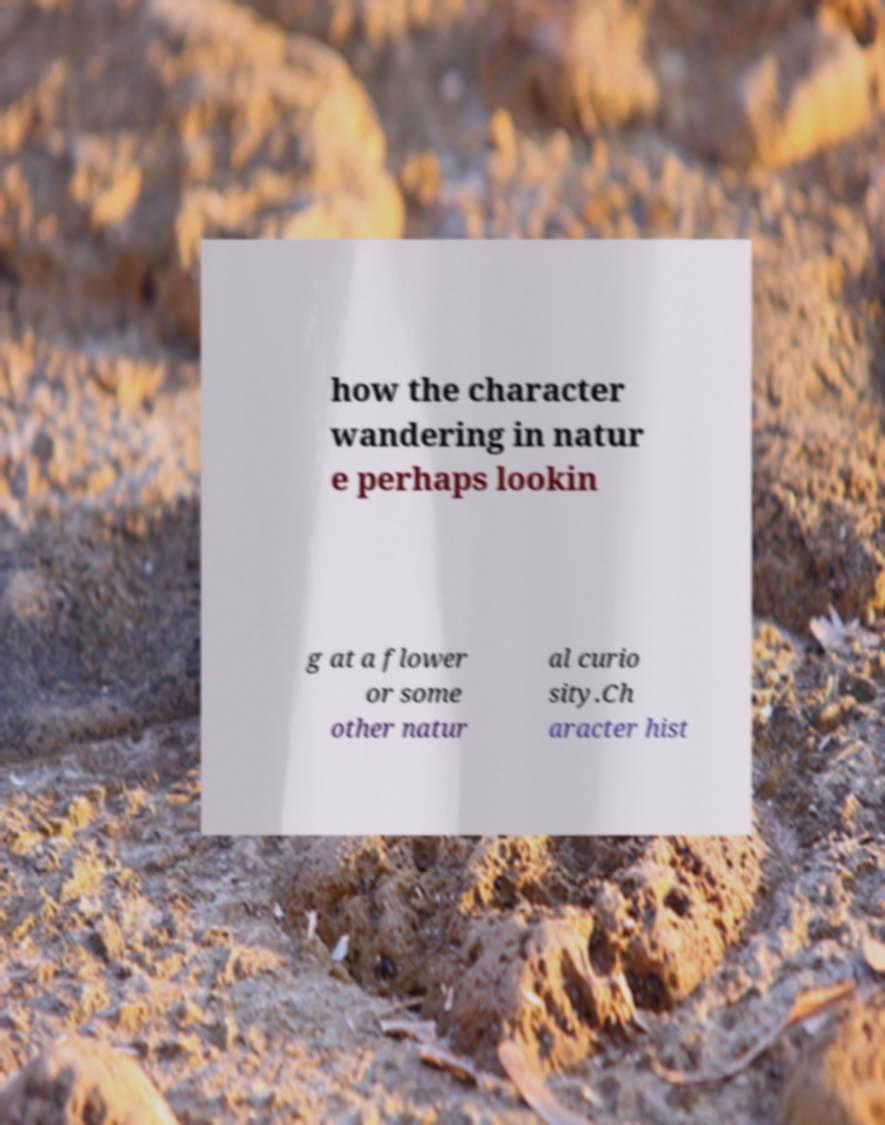For documentation purposes, I need the text within this image transcribed. Could you provide that? how the character wandering in natur e perhaps lookin g at a flower or some other natur al curio sity.Ch aracter hist 